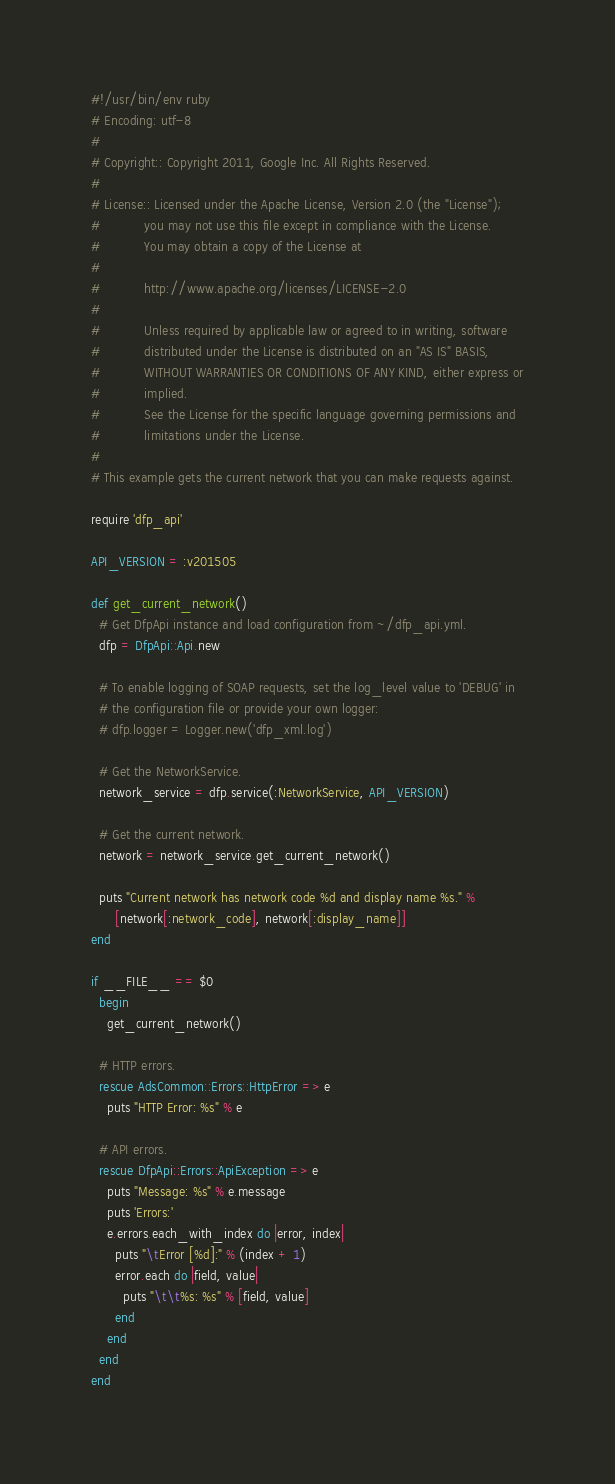Convert code to text. <code><loc_0><loc_0><loc_500><loc_500><_Ruby_>#!/usr/bin/env ruby
# Encoding: utf-8
#
# Copyright:: Copyright 2011, Google Inc. All Rights Reserved.
#
# License:: Licensed under the Apache License, Version 2.0 (the "License");
#           you may not use this file except in compliance with the License.
#           You may obtain a copy of the License at
#
#           http://www.apache.org/licenses/LICENSE-2.0
#
#           Unless required by applicable law or agreed to in writing, software
#           distributed under the License is distributed on an "AS IS" BASIS,
#           WITHOUT WARRANTIES OR CONDITIONS OF ANY KIND, either express or
#           implied.
#           See the License for the specific language governing permissions and
#           limitations under the License.
#
# This example gets the current network that you can make requests against.

require 'dfp_api'

API_VERSION = :v201505

def get_current_network()
  # Get DfpApi instance and load configuration from ~/dfp_api.yml.
  dfp = DfpApi::Api.new

  # To enable logging of SOAP requests, set the log_level value to 'DEBUG' in
  # the configuration file or provide your own logger:
  # dfp.logger = Logger.new('dfp_xml.log')

  # Get the NetworkService.
  network_service = dfp.service(:NetworkService, API_VERSION)

  # Get the current network.
  network = network_service.get_current_network()

  puts "Current network has network code %d and display name %s." %
      [network[:network_code], network[:display_name]]
end

if __FILE__ == $0
  begin
    get_current_network()

  # HTTP errors.
  rescue AdsCommon::Errors::HttpError => e
    puts "HTTP Error: %s" % e

  # API errors.
  rescue DfpApi::Errors::ApiException => e
    puts "Message: %s" % e.message
    puts 'Errors:'
    e.errors.each_with_index do |error, index|
      puts "\tError [%d]:" % (index + 1)
      error.each do |field, value|
        puts "\t\t%s: %s" % [field, value]
      end
    end
  end
end
</code> 